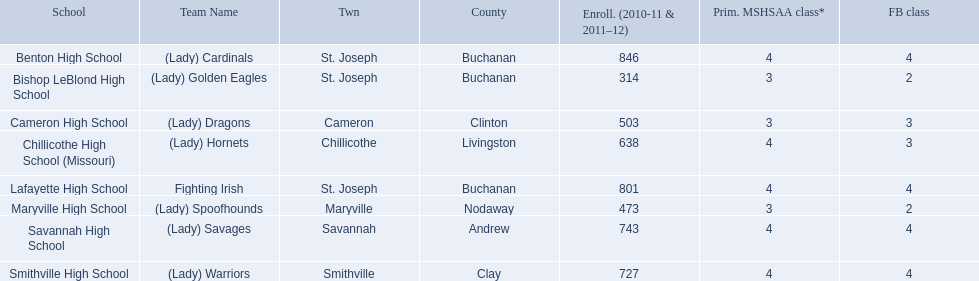Parse the table in full. {'header': ['School', 'Team Name', 'Twn', 'County', 'Enroll. (2010-11 & 2011–12)', 'Prim. MSHSAA class*', 'FB class'], 'rows': [['Benton High School', '(Lady) Cardinals', 'St. Joseph', 'Buchanan', '846', '4', '4'], ['Bishop LeBlond High School', '(Lady) Golden Eagles', 'St. Joseph', 'Buchanan', '314', '3', '2'], ['Cameron High School', '(Lady) Dragons', 'Cameron', 'Clinton', '503', '3', '3'], ['Chillicothe High School (Missouri)', '(Lady) Hornets', 'Chillicothe', 'Livingston', '638', '4', '3'], ['Lafayette High School', 'Fighting Irish', 'St. Joseph', 'Buchanan', '801', '4', '4'], ['Maryville High School', '(Lady) Spoofhounds', 'Maryville', 'Nodaway', '473', '3', '2'], ['Savannah High School', '(Lady) Savages', 'Savannah', 'Andrew', '743', '4', '4'], ['Smithville High School', '(Lady) Warriors', 'Smithville', 'Clay', '727', '4', '4']]} What are the three schools in the town of st. joseph? St. Joseph, St. Joseph, St. Joseph. Of the three schools in st. joseph which school's team name does not depict a type of animal? Lafayette High School. 